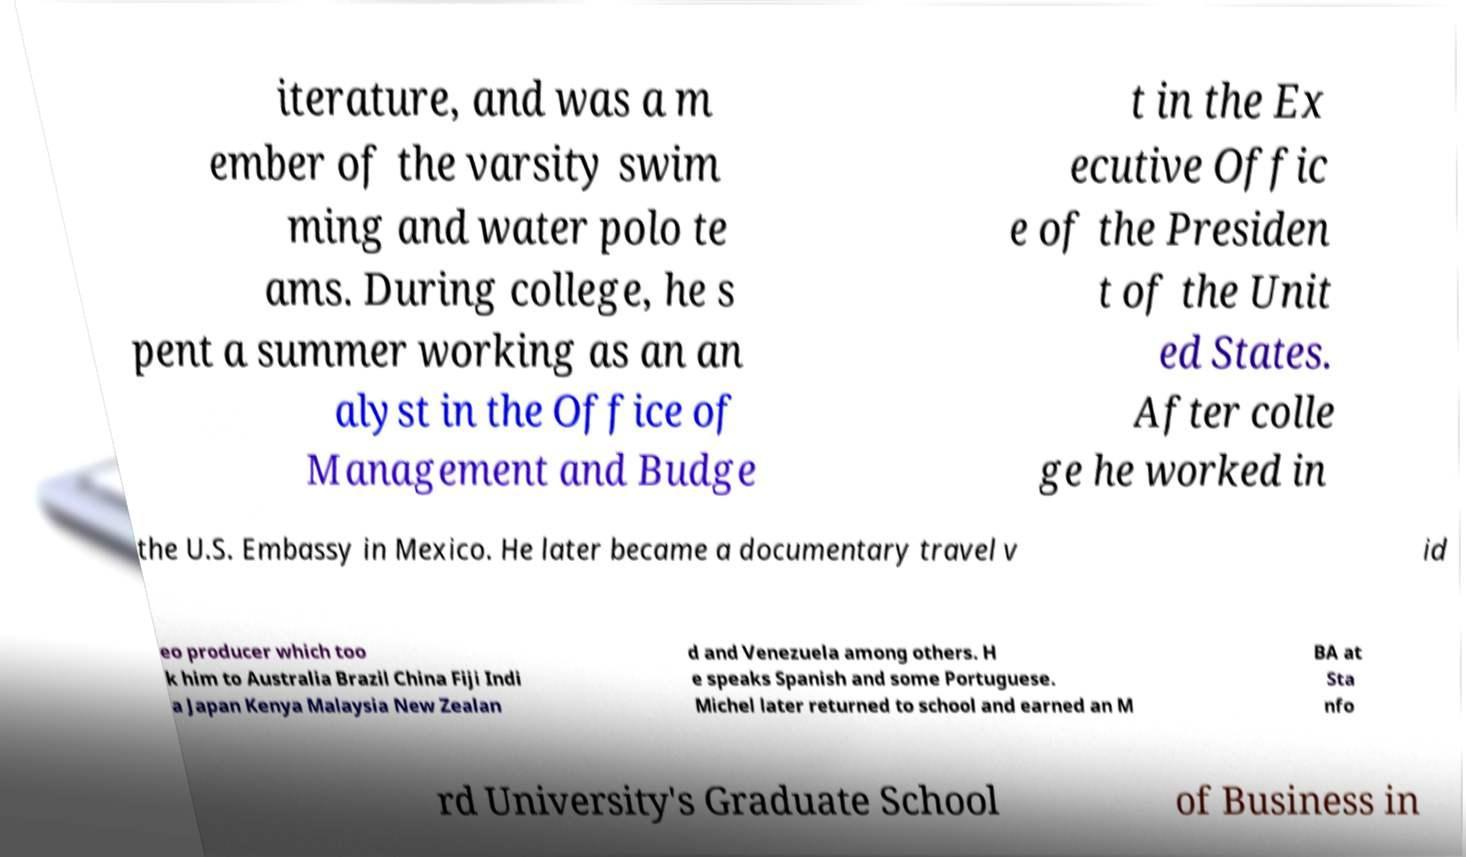Can you accurately transcribe the text from the provided image for me? iterature, and was a m ember of the varsity swim ming and water polo te ams. During college, he s pent a summer working as an an alyst in the Office of Management and Budge t in the Ex ecutive Offic e of the Presiden t of the Unit ed States. After colle ge he worked in the U.S. Embassy in Mexico. He later became a documentary travel v id eo producer which too k him to Australia Brazil China Fiji Indi a Japan Kenya Malaysia New Zealan d and Venezuela among others. H e speaks Spanish and some Portuguese. Michel later returned to school and earned an M BA at Sta nfo rd University's Graduate School of Business in 